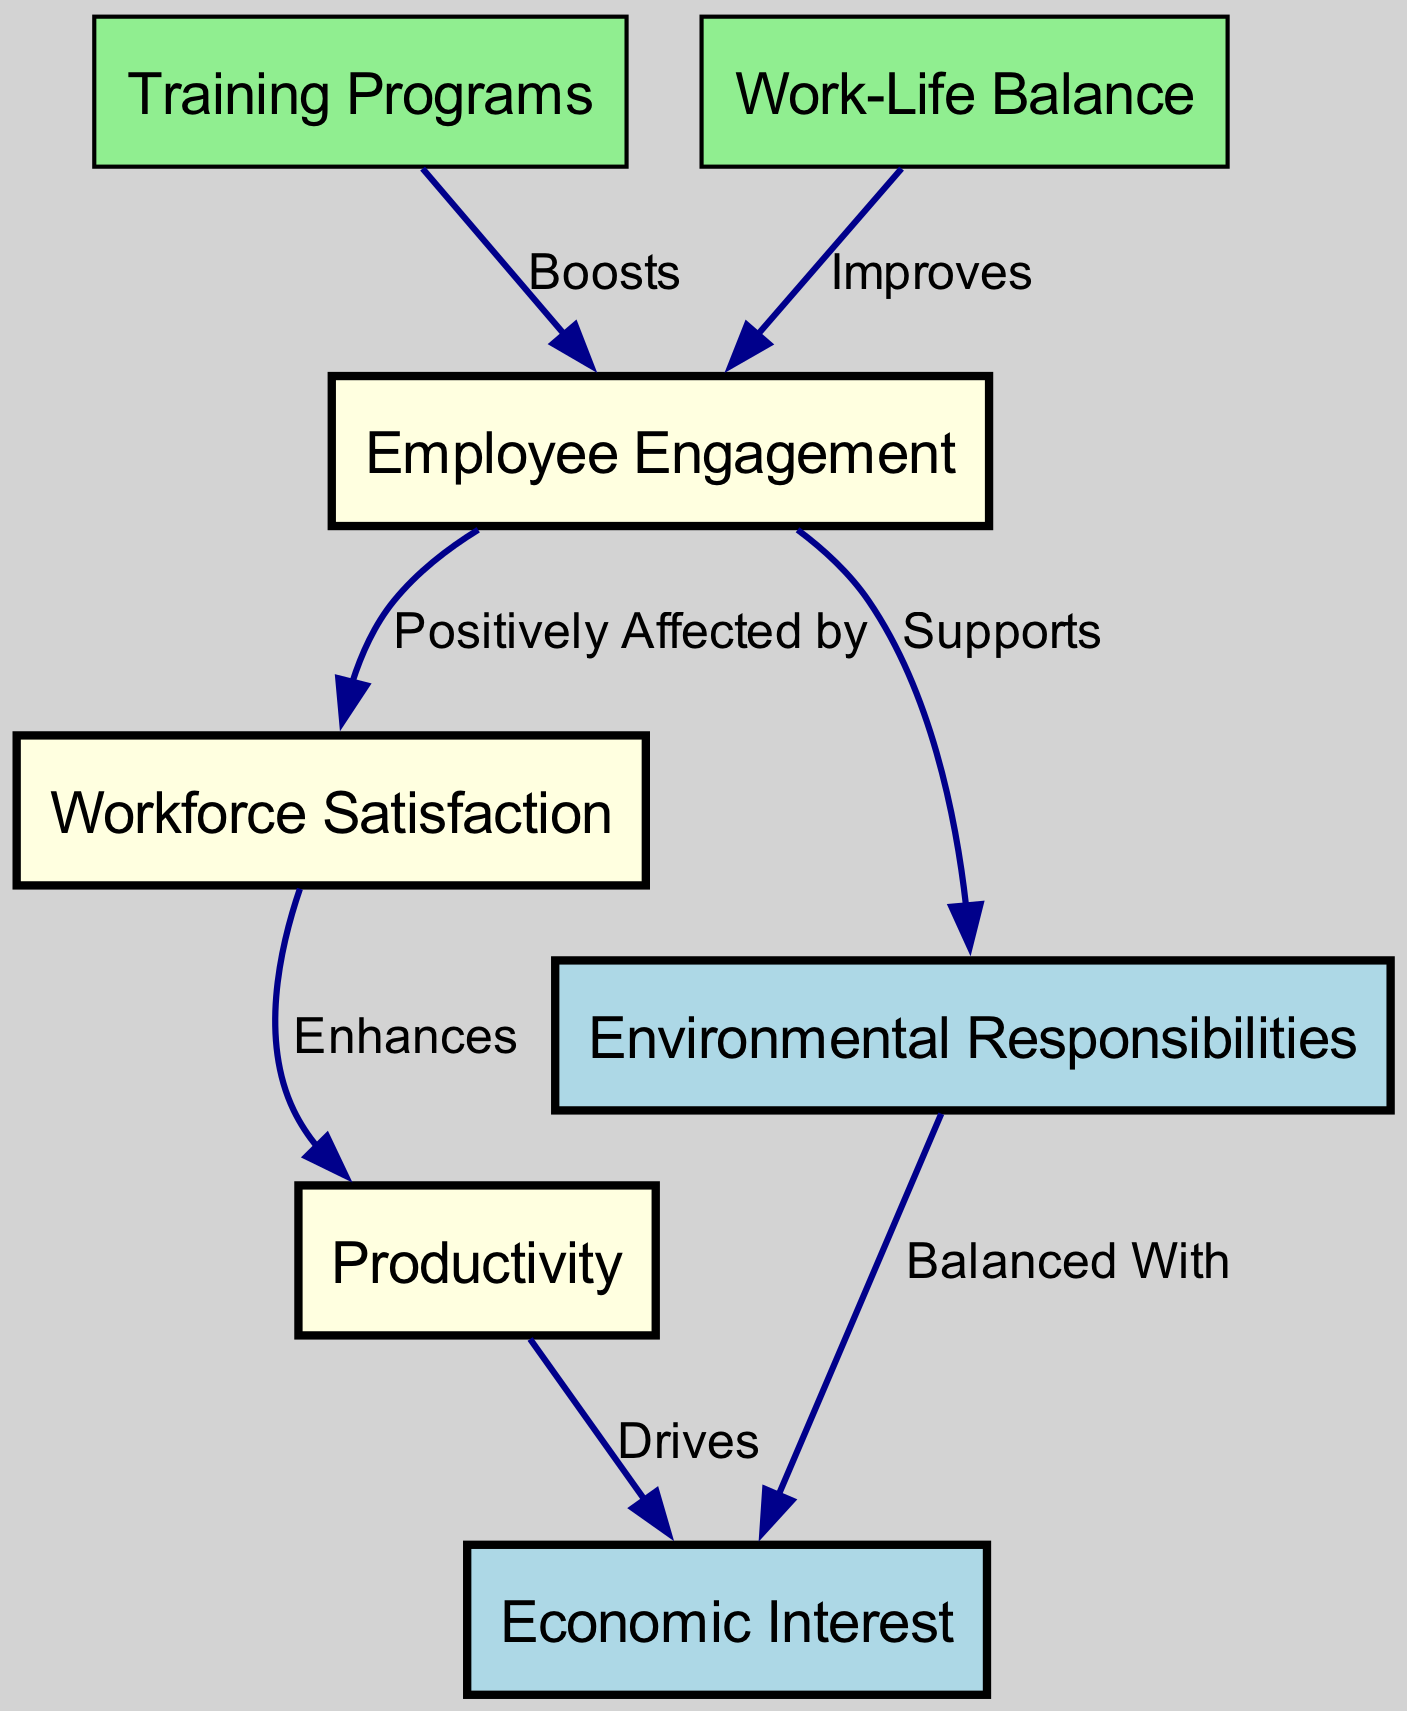What is the highest level node in the diagram? The highest-level node is often considered as the one that does not have any inputs, indicating that it is a starting point or an overarching concept. In this diagram, "Employee Engagement" serves this purpose as it is linked positively to "Workforce Satisfaction."
Answer: Employee Engagement How many nodes are present in the diagram? The total number of nodes is counted by identifying each unique label in the node list. There are seven distinct nodes representing different concepts related to workforce satisfaction and productivity.
Answer: 7 What relationship exists between "Workforce Satisfaction" and "Productivity"? In the diagram, the label on the edge connecting these two nodes states that "Workforce Satisfaction" enhances "Productivity," indicating a positive correlation.
Answer: Enhances Which node has the most connections to other nodes? By analyzing the edges, "Employee Engagement" shows multiple connections: it positively affects "Workforce Satisfaction" and is supported by "Training Programs" and "Work-Life Balance," illustrating that it is central to several relationships in the diagram.
Answer: Employee Engagement How does "Training Programs" influence "Employee Engagement"? According to the edge connecting these two nodes, "Training Programs" boosts "Employee Engagement," highlighting a direct impact where improved training leads to higher engagement levels among employees.
Answer: Boosts Which two nodes are balanced with "Economic Interest"? The diagram explicitly states that "Environmental Responsibilities" are balanced with "Economic Interest," indicating the need to consider both factors alike for overall organizational strategy and impact assessment.
Answer: Environmental Responsibilities What is the purpose of the node "Work-Life Balance"? The diagram shows that "Work-Life Balance" improves "Employee Engagement," suggesting that the primary purpose of this node is to indicate the significance of maintaining a healthy work-life balance to enhance employee engagement levels.
Answer: Improves How many relationships focus on enhancing employee engagement? By reviewing the edges, we note that both "Training Programs" and "Work-Life Balance" point toward "Employee Engagement," indicating two distinct relationships that focus on enhancing engagement.
Answer: 2 In what way does "Employee Engagement" affect the node related to environmental ethics? The edge indicates that "Employee Engagement" supports "Environmental Responsibilities," implying that higher engagement may lead to a more sustainable approach and consideration of environmental factors in the workforce.
Answer: Supports 